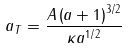Convert formula to latex. <formula><loc_0><loc_0><loc_500><loc_500>a _ { T } = \frac { A \left ( a + 1 \right ) ^ { 3 / 2 } } { \kappa a ^ { 1 / 2 } }</formula> 